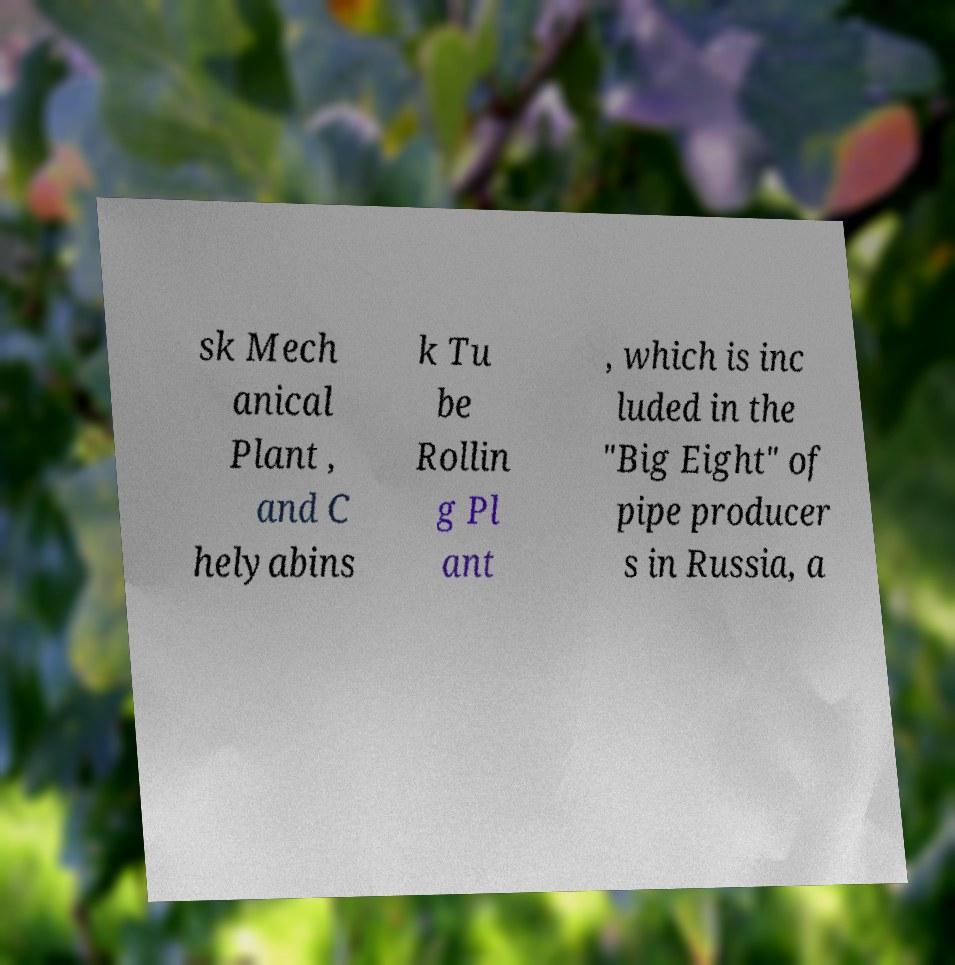Could you extract and type out the text from this image? sk Mech anical Plant , and C helyabins k Tu be Rollin g Pl ant , which is inc luded in the "Big Eight" of pipe producer s in Russia, a 